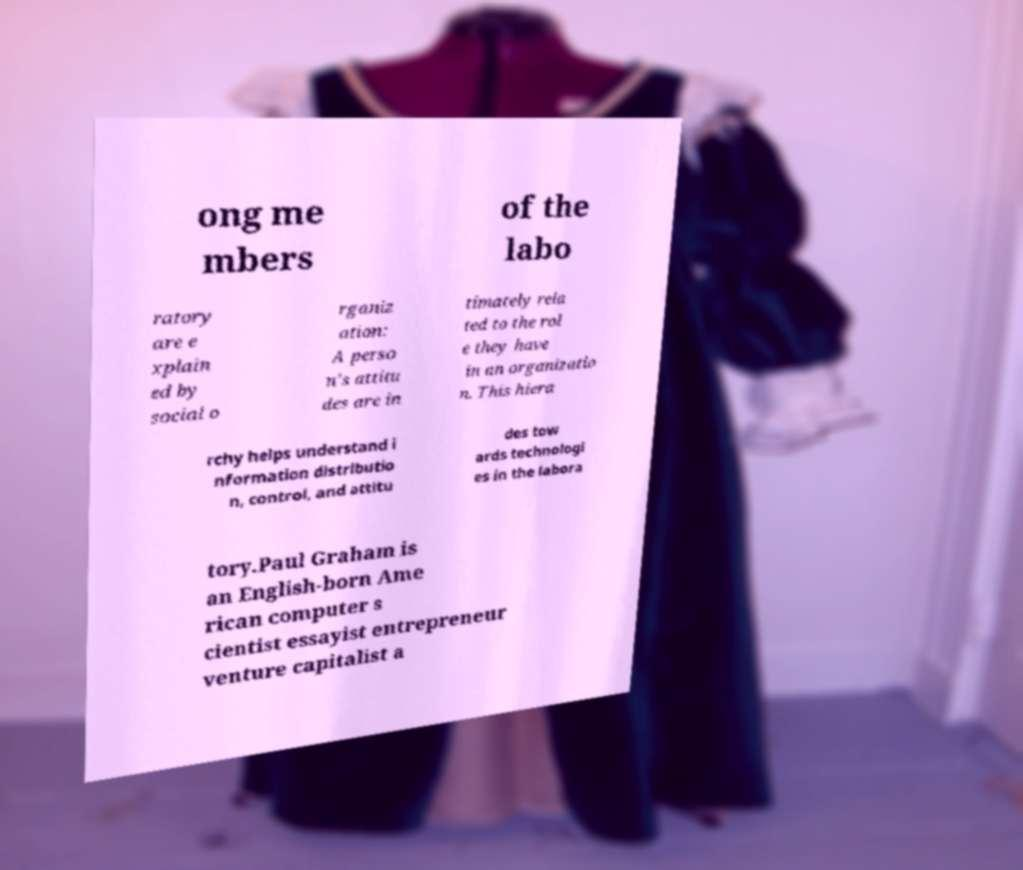I need the written content from this picture converted into text. Can you do that? ong me mbers of the labo ratory are e xplain ed by social o rganiz ation: A perso n's attitu des are in timately rela ted to the rol e they have in an organizatio n. This hiera rchy helps understand i nformation distributio n, control, and attitu des tow ards technologi es in the labora tory.Paul Graham is an English-born Ame rican computer s cientist essayist entrepreneur venture capitalist a 